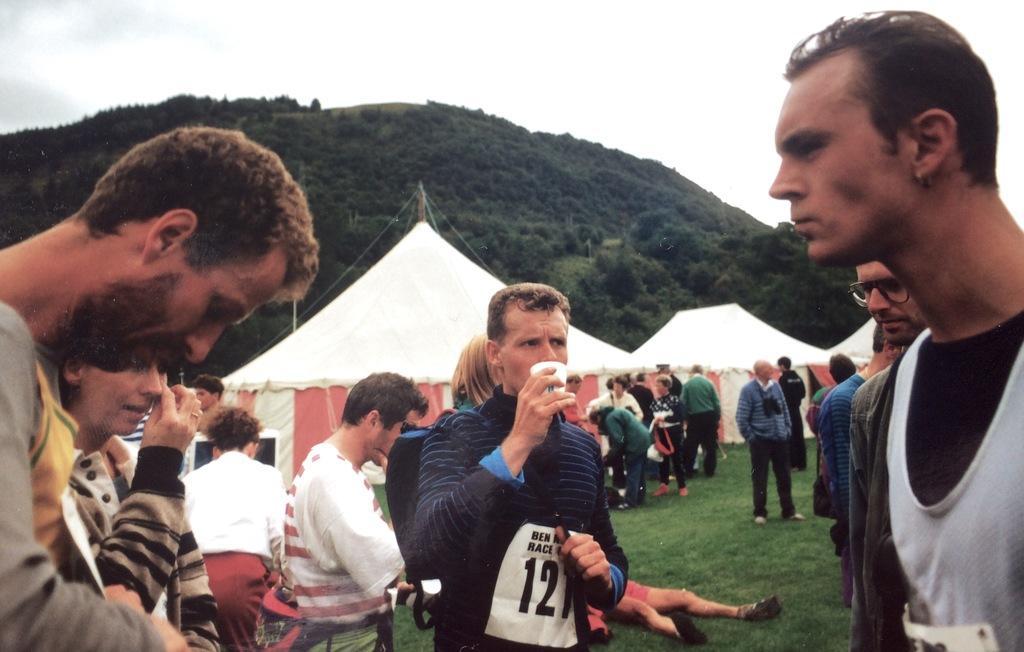Can you describe this image briefly? In this image I can see number of persons are standing on the ground. In the background I can see few tents which are white and red in color, a mountain, few trees on the mountain and the sky. 